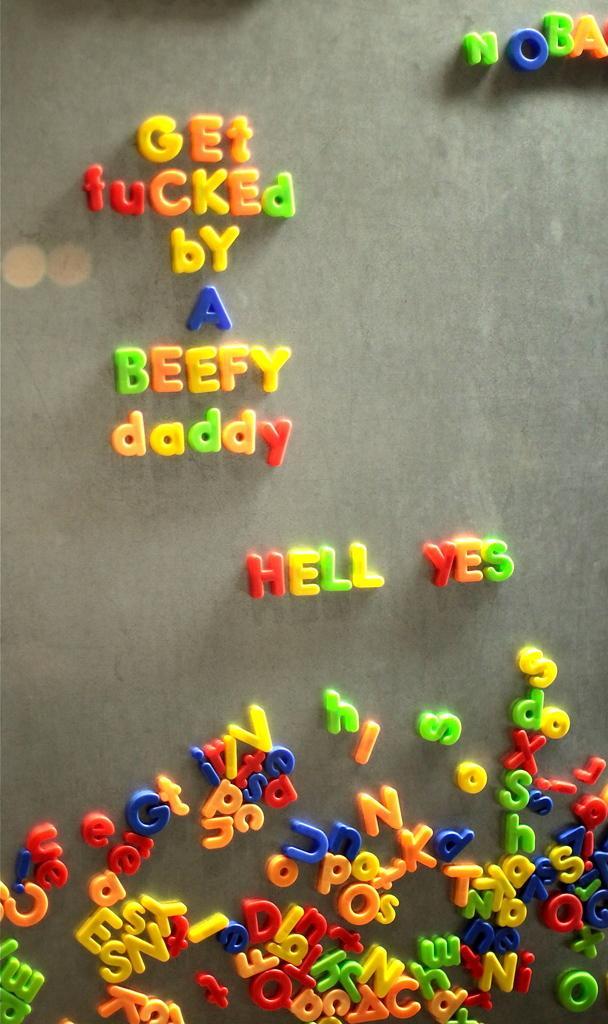Can you describe this image briefly? There are different colored alphabets on a surface. 